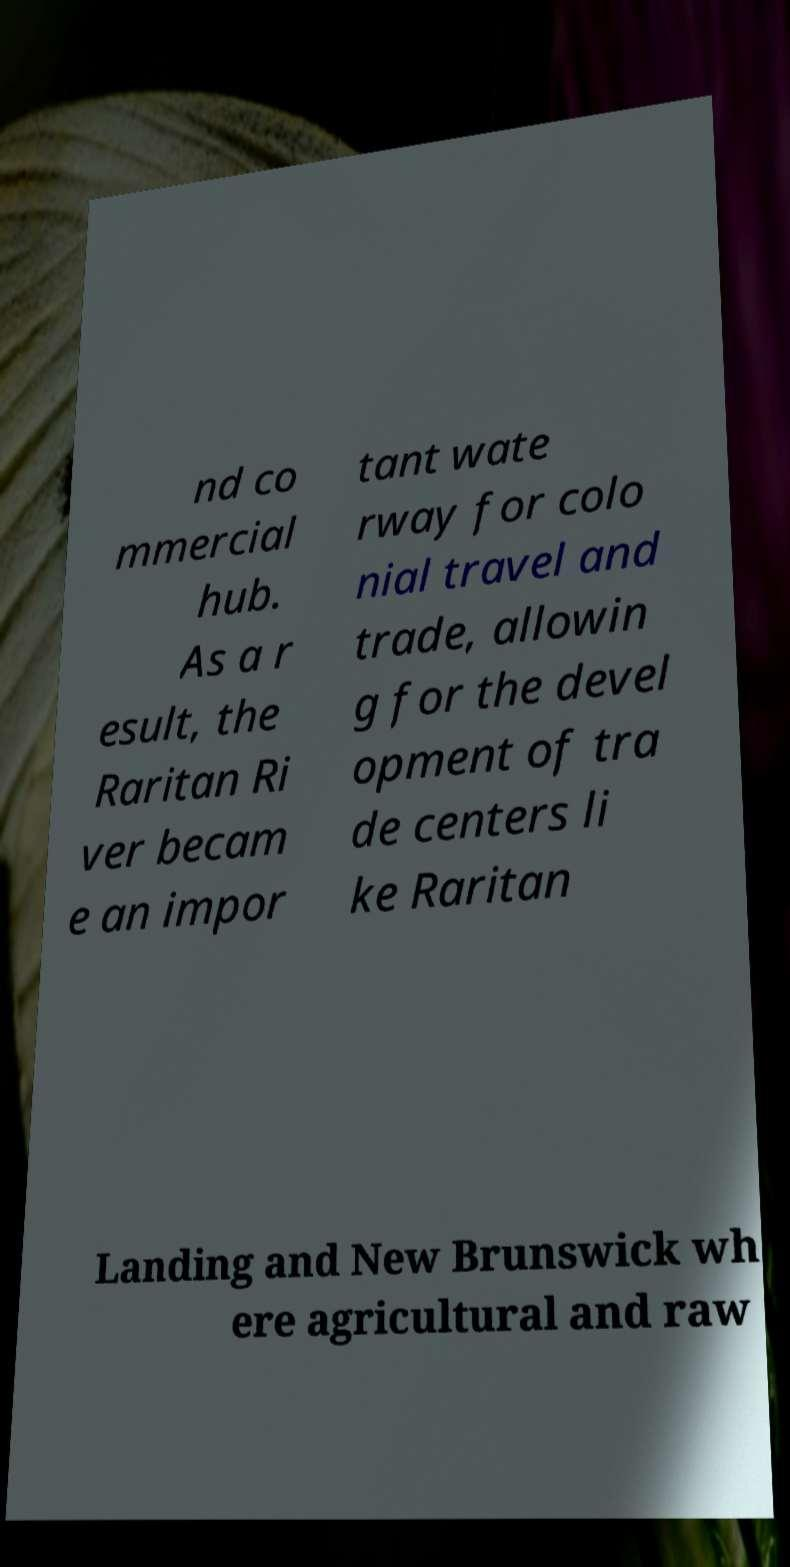Can you accurately transcribe the text from the provided image for me? nd co mmercial hub. As a r esult, the Raritan Ri ver becam e an impor tant wate rway for colo nial travel and trade, allowin g for the devel opment of tra de centers li ke Raritan Landing and New Brunswick wh ere agricultural and raw 